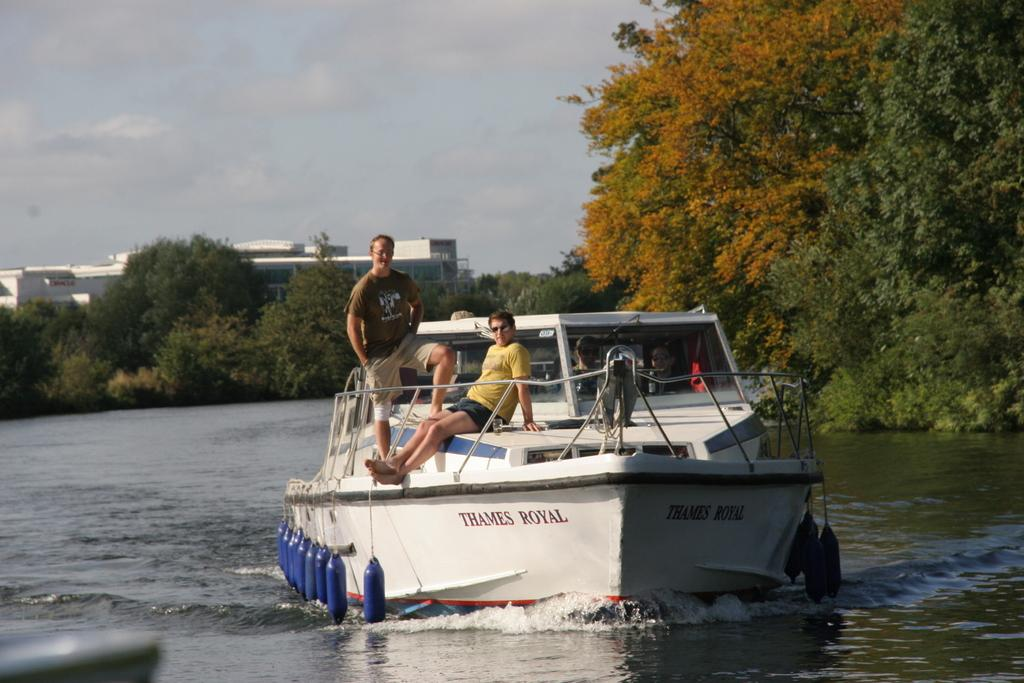What type of vehicle is on the water in the image? There is a white color boat on the water in the image. What feature does the boat have? The boat has a railing. Who is on the boat? There are people on the boat. What can be seen in the background of the image? There are trees, a building, and the sky visible in the background of the image. What type of owl can be seen sitting on the railing of the boat in the image? There is no owl present on the railing of the boat in the image. What type of sticks are being used by the people on the boat in the image? There is no indication of any sticks being used by the people on the boat in the image. 